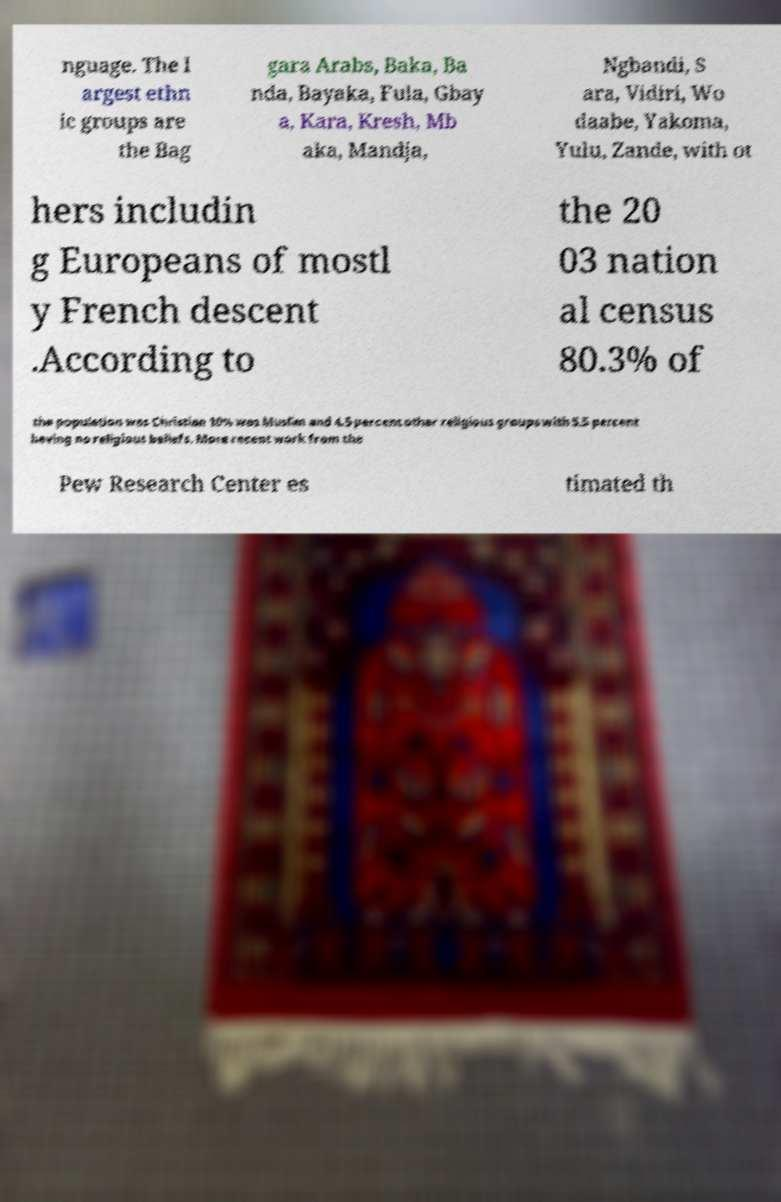Can you accurately transcribe the text from the provided image for me? nguage. The l argest ethn ic groups are the Bag gara Arabs, Baka, Ba nda, Bayaka, Fula, Gbay a, Kara, Kresh, Mb aka, Mandja, Ngbandi, S ara, Vidiri, Wo daabe, Yakoma, Yulu, Zande, with ot hers includin g Europeans of mostl y French descent .According to the 20 03 nation al census 80.3% of the population was Christian 10% was Muslim and 4.5 percent other religious groups with 5.5 percent having no religious beliefs. More recent work from the Pew Research Center es timated th 